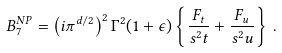<formula> <loc_0><loc_0><loc_500><loc_500>B _ { 7 } ^ { N P } = { \left ( i \pi ^ { d / 2 } \right ) } ^ { 2 } \, \Gamma ^ { 2 } ( 1 + \epsilon ) \left \{ \frac { F _ { t } } { s ^ { 2 } t } + \frac { F _ { u } } { s ^ { 2 } u } \right \} \, .</formula> 